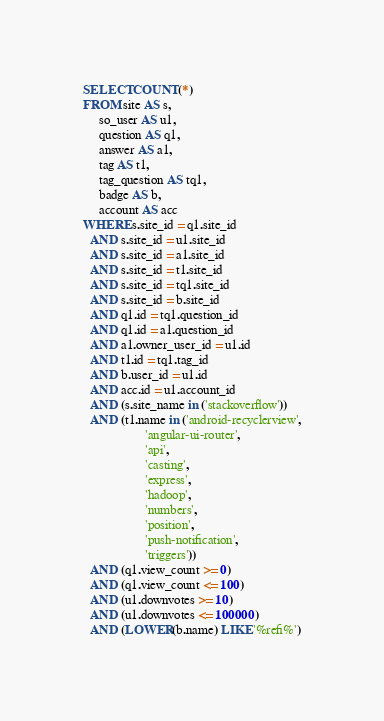<code> <loc_0><loc_0><loc_500><loc_500><_SQL_>SELECT COUNT(*)
FROM site AS s,
     so_user AS u1,
     question AS q1,
     answer AS a1,
     tag AS t1,
     tag_question AS tq1,
     badge AS b,
     account AS acc
WHERE s.site_id = q1.site_id
  AND s.site_id = u1.site_id
  AND s.site_id = a1.site_id
  AND s.site_id = t1.site_id
  AND s.site_id = tq1.site_id
  AND s.site_id = b.site_id
  AND q1.id = tq1.question_id
  AND q1.id = a1.question_id
  AND a1.owner_user_id = u1.id
  AND t1.id = tq1.tag_id
  AND b.user_id = u1.id
  AND acc.id = u1.account_id
  AND (s.site_name in ('stackoverflow'))
  AND (t1.name in ('android-recyclerview',
                   'angular-ui-router',
                   'api',
                   'casting',
                   'express',
                   'hadoop',
                   'numbers',
                   'position',
                   'push-notification',
                   'triggers'))
  AND (q1.view_count >= 0)
  AND (q1.view_count <= 100)
  AND (u1.downvotes >= 10)
  AND (u1.downvotes <= 100000)
  AND (LOWER(b.name) LIKE '%refi%')</code> 